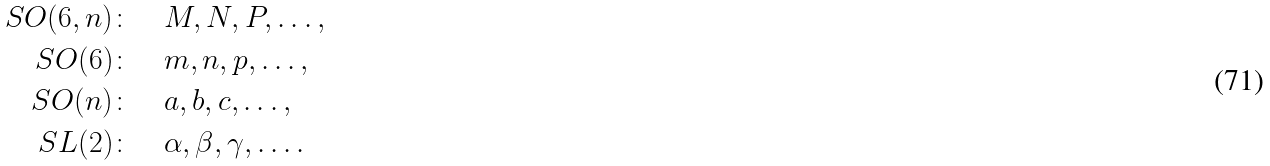Convert formula to latex. <formula><loc_0><loc_0><loc_500><loc_500>S O ( 6 , n ) \colon & \quad M , N , P , \dots , \\ S O ( 6 ) \colon & \quad m , n , p , \dots , \\ S O ( n ) \colon & \quad a , b , c , \dots , \\ S L ( 2 ) \colon & \quad \alpha , \beta , \gamma , \dots .</formula> 